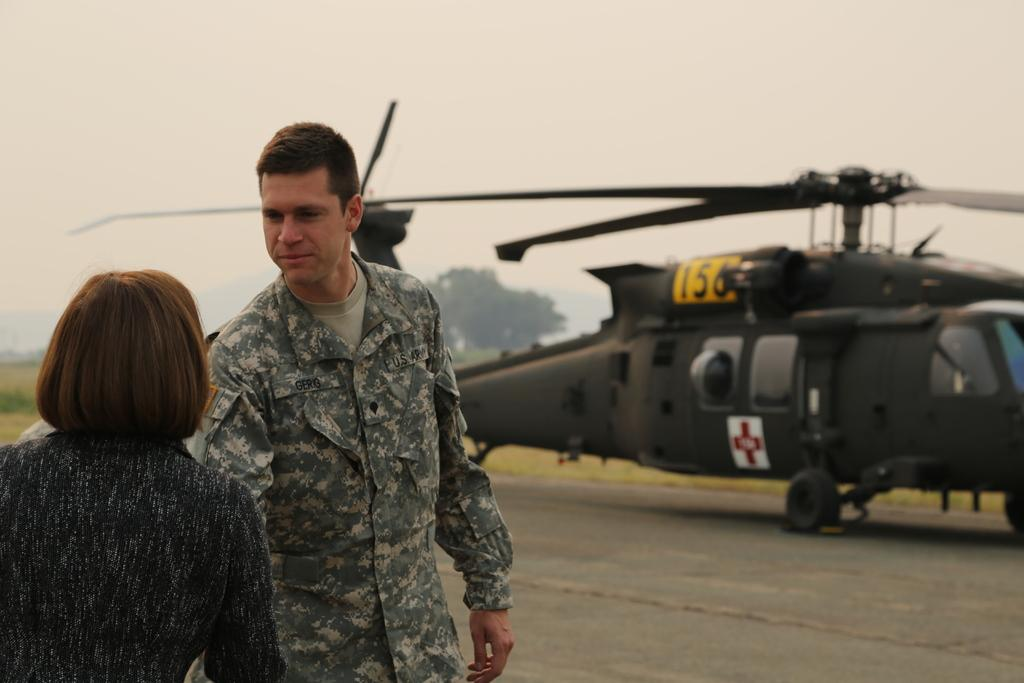How many people are in the image? There are two persons standing on the ground in the image. What is the main mode of transportation in the image? There is a helicopter in the image. What type of surface can be seen in the image? There are wheels visible in the image. What type of vegetation is present in the image? There are many trees at the back of the image, and there is grass in the image. What is visible at the top of the image? The sky is visible at the top of the image. What type of bean is growing on the helicopter in the image? There are no beans present in the image, and the helicopter is not a place where beans would grow. What kind of noise can be heard coming from the trees in the image? There is no sound present in the image, so it is not possible to determine what kind of noise might be heard. 